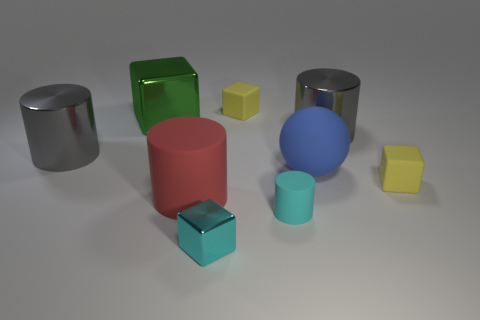Add 1 green shiny cubes. How many objects exist? 10 Subtract all cylinders. How many objects are left? 5 Subtract all spheres. Subtract all green shiny cubes. How many objects are left? 7 Add 7 large red matte objects. How many large red matte objects are left? 8 Add 3 large gray cylinders. How many large gray cylinders exist? 5 Subtract 0 yellow cylinders. How many objects are left? 9 